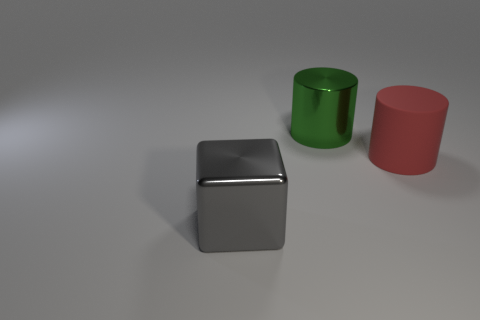Add 3 big red objects. How many objects exist? 6 Subtract 1 cubes. How many cubes are left? 0 Subtract all blocks. How many objects are left? 2 Subtract all green cylinders. How many cylinders are left? 1 Add 1 green objects. How many green objects are left? 2 Add 2 tiny cyan matte balls. How many tiny cyan matte balls exist? 2 Subtract 0 blue spheres. How many objects are left? 3 Subtract all cyan blocks. Subtract all red cylinders. How many blocks are left? 1 Subtract all red blocks. How many green cylinders are left? 1 Subtract all big cyan things. Subtract all large shiny objects. How many objects are left? 1 